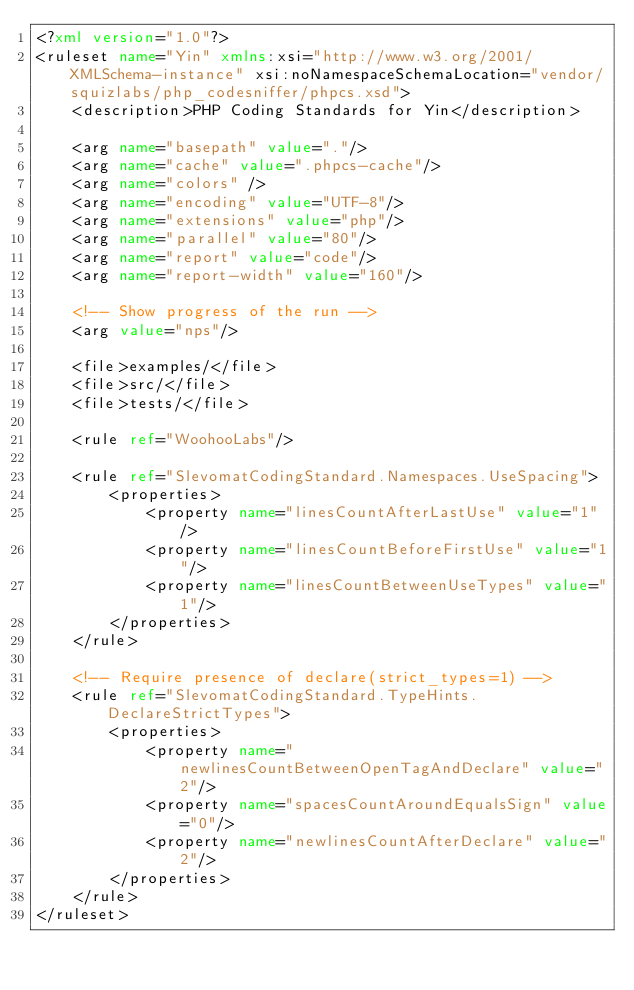<code> <loc_0><loc_0><loc_500><loc_500><_XML_><?xml version="1.0"?>
<ruleset name="Yin" xmlns:xsi="http://www.w3.org/2001/XMLSchema-instance" xsi:noNamespaceSchemaLocation="vendor/squizlabs/php_codesniffer/phpcs.xsd">
    <description>PHP Coding Standards for Yin</description>

    <arg name="basepath" value="."/>
    <arg name="cache" value=".phpcs-cache"/>
    <arg name="colors" />
    <arg name="encoding" value="UTF-8"/>
    <arg name="extensions" value="php"/>
    <arg name="parallel" value="80"/>
    <arg name="report" value="code"/>
    <arg name="report-width" value="160"/>

    <!-- Show progress of the run -->
    <arg value="nps"/>

    <file>examples/</file>
    <file>src/</file>
    <file>tests/</file>

    <rule ref="WoohooLabs"/>

    <rule ref="SlevomatCodingStandard.Namespaces.UseSpacing">
        <properties>
            <property name="linesCountAfterLastUse" value="1"/>
            <property name="linesCountBeforeFirstUse" value="1"/>
            <property name="linesCountBetweenUseTypes" value="1"/>
        </properties>
    </rule>

    <!-- Require presence of declare(strict_types=1) -->
    <rule ref="SlevomatCodingStandard.TypeHints.DeclareStrictTypes">
        <properties>
            <property name="newlinesCountBetweenOpenTagAndDeclare" value="2"/>
            <property name="spacesCountAroundEqualsSign" value="0"/>
            <property name="newlinesCountAfterDeclare" value="2"/>
        </properties>
    </rule>
</ruleset>
</code> 